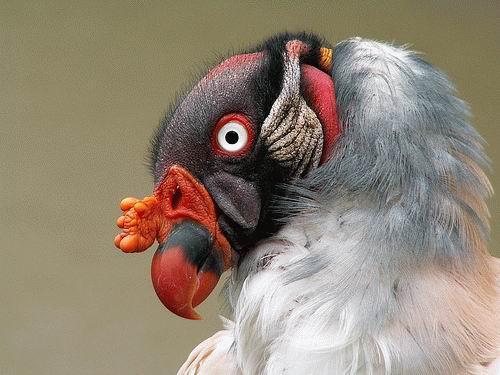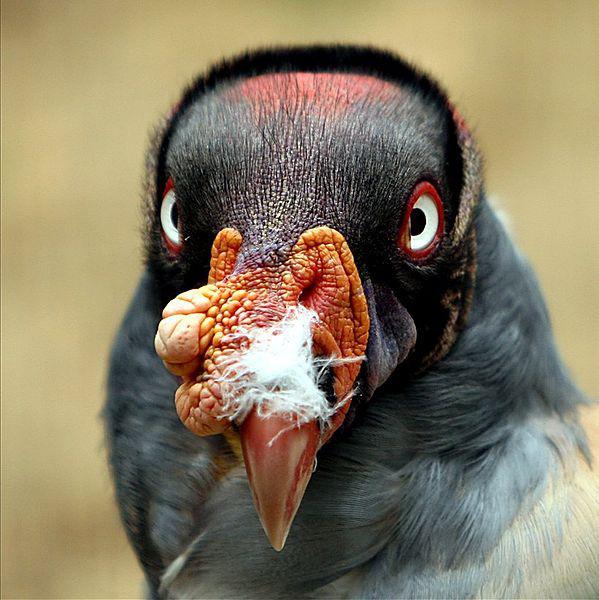The first image is the image on the left, the second image is the image on the right. For the images displayed, is the sentence "A bird has a raised wing in one image." factually correct? Answer yes or no. No. 